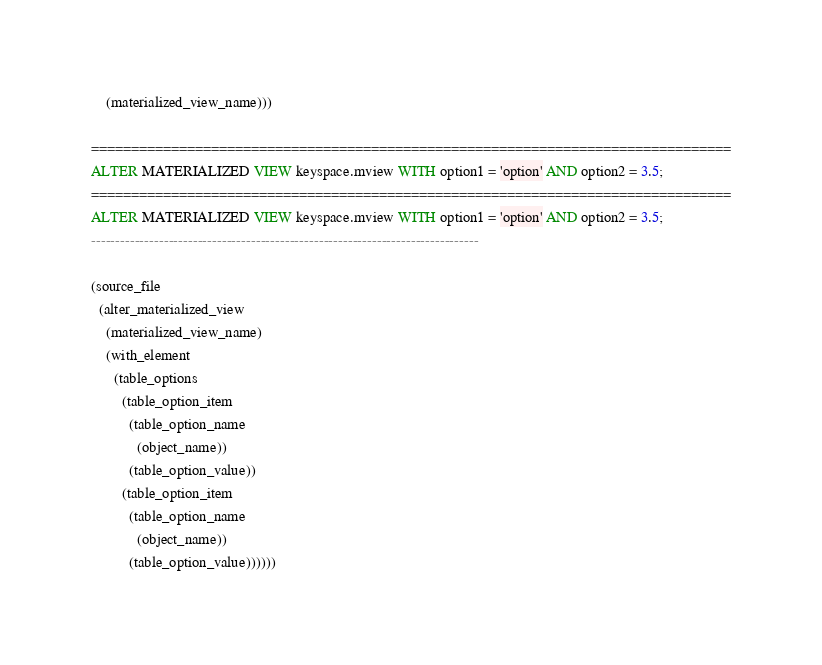<code> <loc_0><loc_0><loc_500><loc_500><_SQL_>    (materialized_view_name)))

================================================================================
ALTER MATERIALIZED VIEW keyspace.mview WITH option1 = 'option' AND option2 = 3.5;
================================================================================
ALTER MATERIALIZED VIEW keyspace.mview WITH option1 = 'option' AND option2 = 3.5;
--------------------------------------------------------------------------------

(source_file
  (alter_materialized_view
    (materialized_view_name)
    (with_element
      (table_options
        (table_option_item
          (table_option_name
            (object_name))
          (table_option_value))
        (table_option_item
          (table_option_name
            (object_name))
          (table_option_value))))))
</code> 